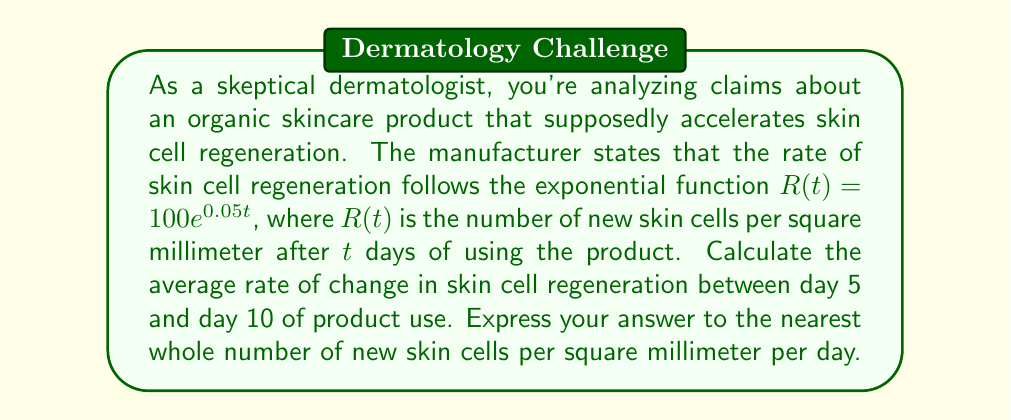Can you answer this question? To solve this problem, we'll use the average rate of change formula for the given exponential function:

1) The average rate of change formula is:
   $$\text{Average rate of change} = \frac{R(t_2) - R(t_1)}{t_2 - t_1}$$

2) We need to calculate $R(5)$ and $R(10)$:
   
   $R(5) = 100e^{0.05(5)} = 100e^{0.25} \approx 128.4025$ cells/mm²
   $R(10) = 100e^{0.05(10)} = 100e^{0.5} \approx 164.8721$ cells/mm²

3) Now we can substitute these values into our formula:
   $$\text{Average rate of change} = \frac{164.8721 - 128.4025}{10 - 5} = \frac{36.4696}{5} \approx 7.2939$$

4) Rounding to the nearest whole number:
   $7.2939 \approx 7$ cells/mm²/day

This result suggests that, on average, the number of new skin cells per square millimeter increases by approximately 7 per day between day 5 and day 10 of product use, according to the manufacturer's claim.
Answer: 7 cells/mm²/day 